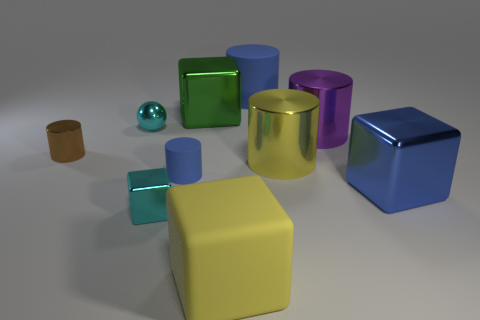Is the blue cube the same size as the brown thing?
Keep it short and to the point. No. What number of things are either yellow rubber cubes or large rubber objects that are behind the shiny ball?
Offer a very short reply. 2. What is the material of the small blue cylinder?
Provide a succinct answer. Rubber. Are there any other things that are the same color as the small metal cylinder?
Provide a succinct answer. No. Is the tiny blue thing the same shape as the brown thing?
Keep it short and to the point. Yes. There is a blue cylinder on the left side of the matte object in front of the shiny object that is on the right side of the purple shiny object; what size is it?
Keep it short and to the point. Small. What number of other things are there of the same material as the cyan block
Keep it short and to the point. 6. There is a metallic cube on the right side of the purple metallic cylinder; what color is it?
Keep it short and to the point. Blue. What material is the blue cylinder that is behind the thing left of the cyan metal object that is to the left of the tiny cyan shiny block made of?
Give a very brief answer. Rubber. Is there a tiny blue thing of the same shape as the big yellow metal object?
Your answer should be very brief. Yes. 